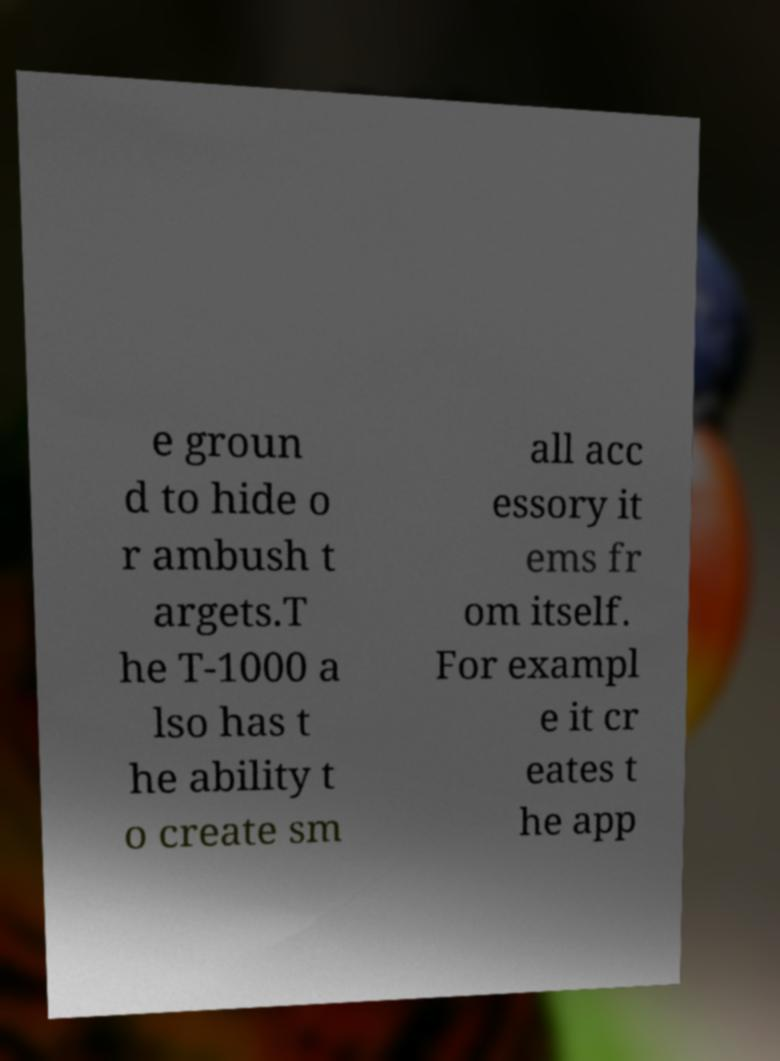What messages or text are displayed in this image? I need them in a readable, typed format. e groun d to hide o r ambush t argets.T he T-1000 a lso has t he ability t o create sm all acc essory it ems fr om itself. For exampl e it cr eates t he app 